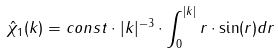Convert formula to latex. <formula><loc_0><loc_0><loc_500><loc_500>\hat { \chi } _ { 1 } ( k ) = c o n s t \cdot | k | ^ { - 3 } \cdot \int _ { 0 } ^ { | k | } r \cdot \sin ( r ) d r</formula> 